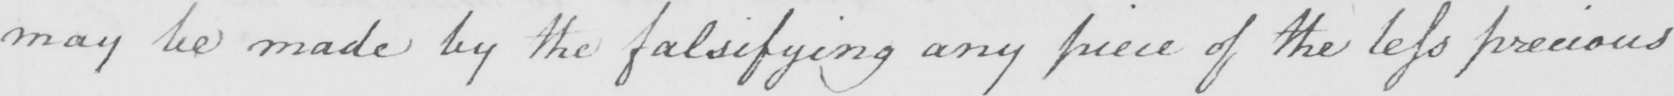What does this handwritten line say? may be made by the falsifying any piece of the less precious 